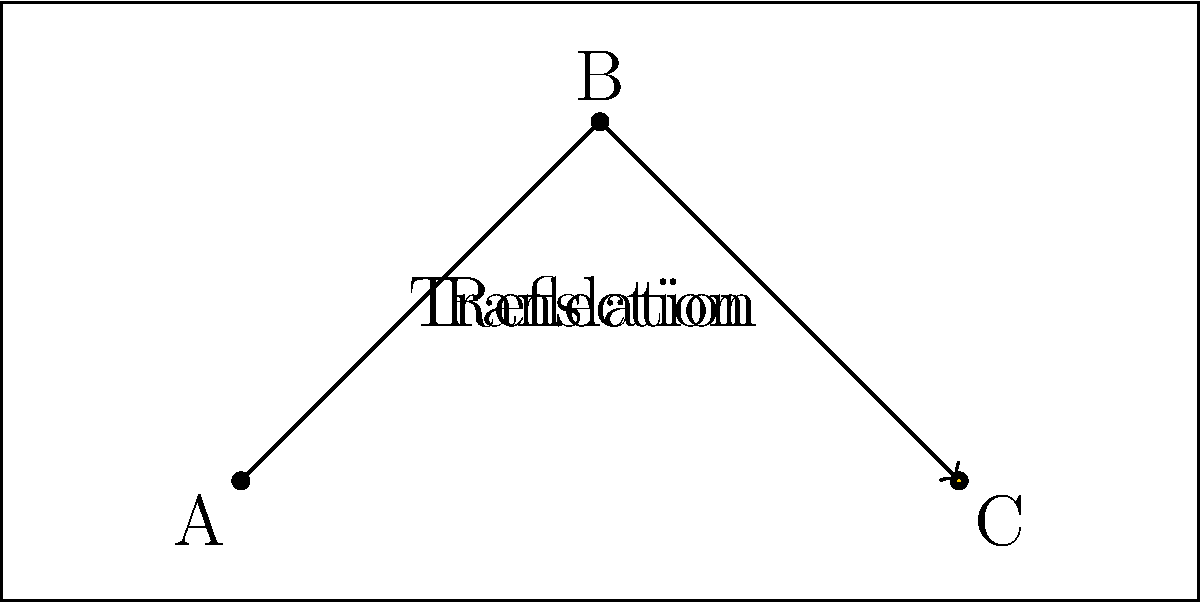In a water polo match, Maartje Keuning performs a lob shot. The ball's trajectory can be described by two transformations: a reflection followed by a translation. If point A(2,1) is the starting position, B(5,4) is the highest point, and C(8,1) is where the ball lands, determine the matrix product that represents this compound transformation. Let's break this down step-by-step:

1) First, we need to find the matrix for the reflection. The line of reflection is the perpendicular bisector of line segment AC.

   Midpoint of AC: $(\frac{2+8}{2}, \frac{1+1}{2}) = (5,1)$
   Slope of AC: $m_{AC} = 0$
   Slope of reflection line: $m_{ref} = \infty$ (vertical line)

   The equation of the reflection line is $x = 5$

   The reflection matrix about $x = 5$ is:
   $$R = \begin{bmatrix} -1 & 0 \\ 0 & 1 \end{bmatrix}$$

2) Now, we need to find the translation vector. After reflection, A(2,1) becomes A'(8,1). To get to C(8,1), we need to translate by (0,0).

   Translation vector: $\vec{t} = \begin{bmatrix} 0 \\ 0 \end{bmatrix}$

3) The translation matrix is:
   $$T = \begin{bmatrix} 1 & 0 & 0 \\ 0 & 1 & 0 \\ 0 & 0 & 1 \end{bmatrix}$$

4) To combine these transformations, we multiply the matrices in reverse order:
   $$TR = \begin{bmatrix} 1 & 0 & 0 \\ 0 & 1 & 0 \\ 0 & 0 & 1 \end{bmatrix} \begin{bmatrix} -1 & 0 & 10 \\ 0 & 1 & 0 \\ 0 & 0 & 1 \end{bmatrix}$$

5) Multiplying these matrices gives us:
   $$TR = \begin{bmatrix} -1 & 0 & 10 \\ 0 & 1 & 0 \\ 0 & 0 & 1 \end{bmatrix}$$

This matrix represents the compound transformation of reflection followed by translation.
Answer: $\begin{bmatrix} -1 & 0 & 10 \\ 0 & 1 & 0 \\ 0 & 0 & 1 \end{bmatrix}$ 